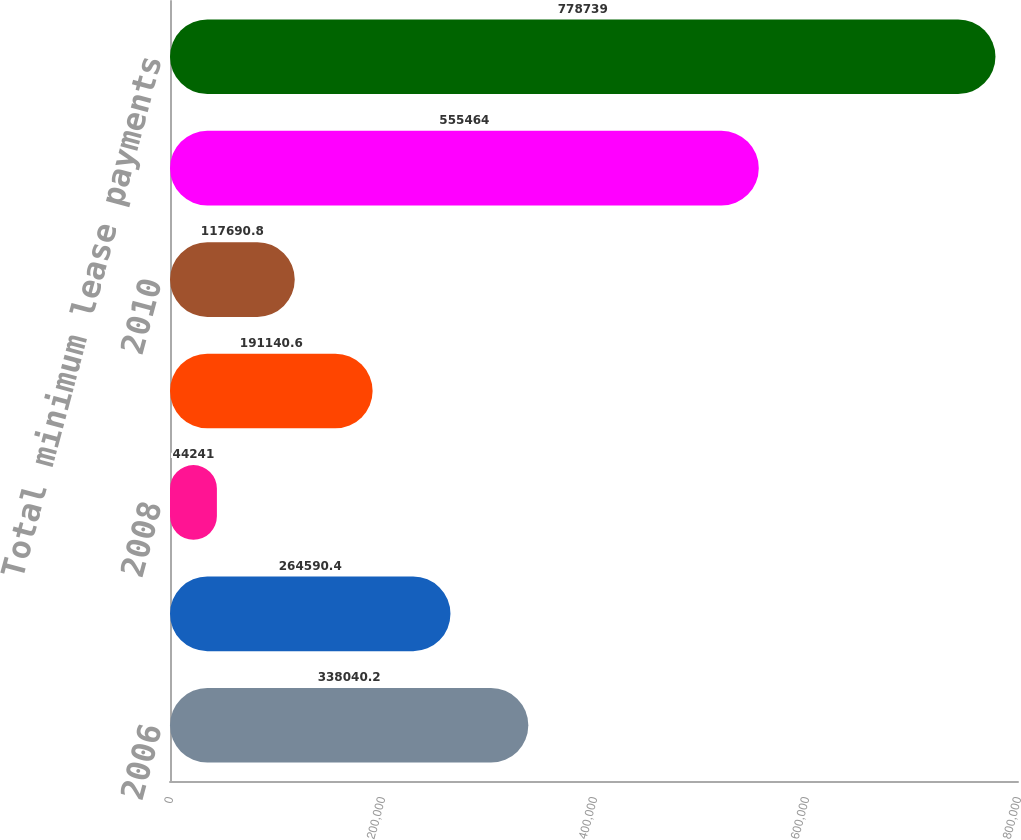<chart> <loc_0><loc_0><loc_500><loc_500><bar_chart><fcel>2006<fcel>2007<fcel>2008<fcel>2009<fcel>2010<fcel>Thereafter<fcel>Total minimum lease payments<nl><fcel>338040<fcel>264590<fcel>44241<fcel>191141<fcel>117691<fcel>555464<fcel>778739<nl></chart> 